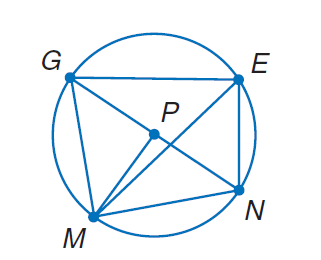Answer the mathemtical geometry problem and directly provide the correct option letter.
Question: In \odot P, m \widehat E N = 66 and m \angle G P M = 89. Find m \angle G M E.
Choices: A: 57 B: 66 C: 89 D: 155 A 